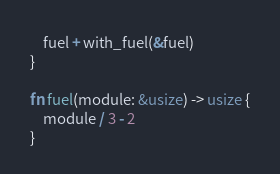<code> <loc_0><loc_0><loc_500><loc_500><_Rust_>    fuel + with_fuel(&fuel)
}

fn fuel(module: &usize) -> usize {
    module / 3 - 2
}
</code> 